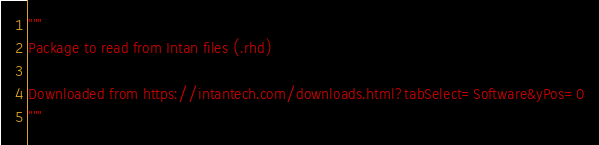<code> <loc_0><loc_0><loc_500><loc_500><_Python_>"""
Package to read from Intan files (.rhd)

Downloaded from https://intantech.com/downloads.html?tabSelect=Software&yPos=0
"""</code> 